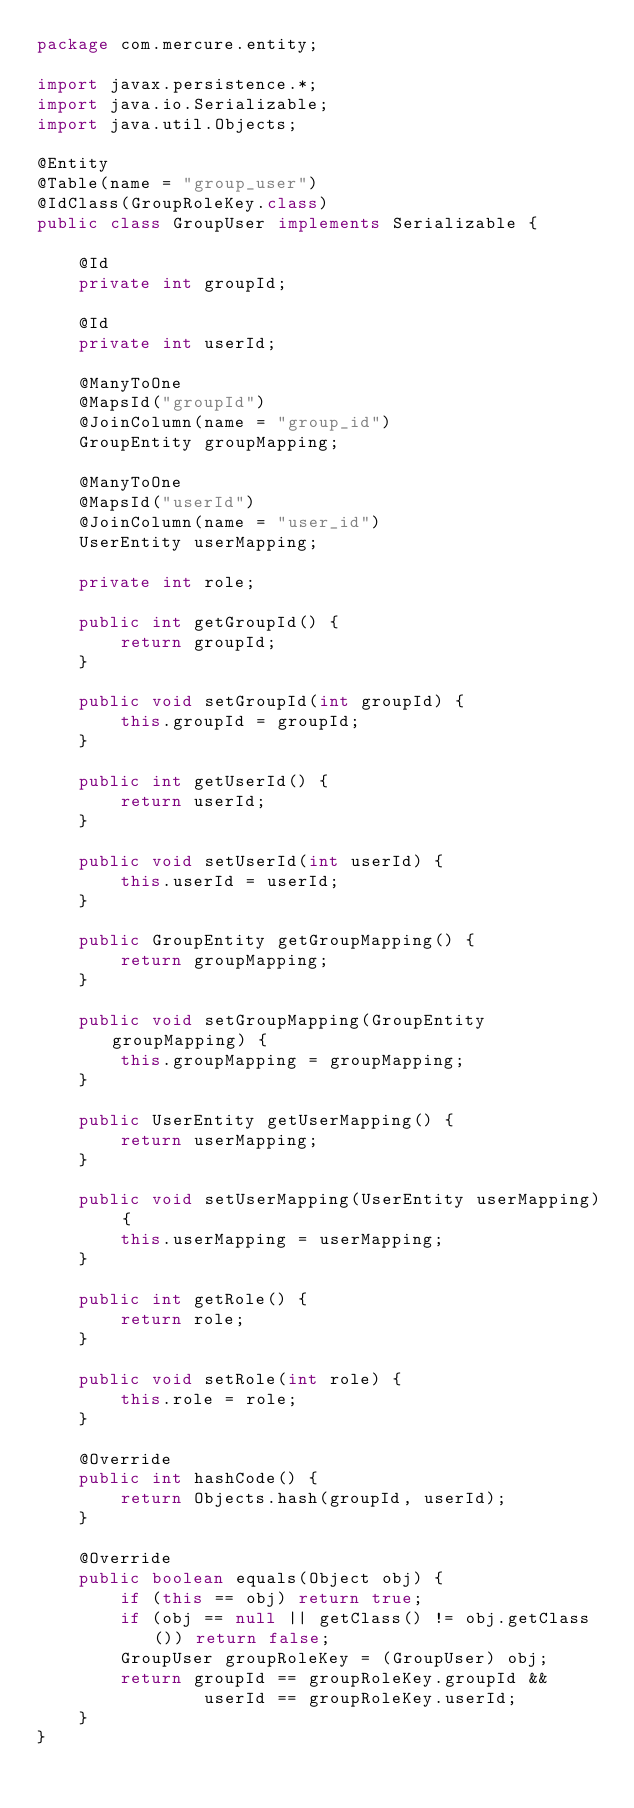Convert code to text. <code><loc_0><loc_0><loc_500><loc_500><_Java_>package com.mercure.entity;

import javax.persistence.*;
import java.io.Serializable;
import java.util.Objects;

@Entity
@Table(name = "group_user")
@IdClass(GroupRoleKey.class)
public class GroupUser implements Serializable {

    @Id
    private int groupId;

    @Id
    private int userId;

    @ManyToOne
    @MapsId("groupId")
    @JoinColumn(name = "group_id")
    GroupEntity groupMapping;

    @ManyToOne
    @MapsId("userId")
    @JoinColumn(name = "user_id")
    UserEntity userMapping;

    private int role;

    public int getGroupId() {
        return groupId;
    }

    public void setGroupId(int groupId) {
        this.groupId = groupId;
    }

    public int getUserId() {
        return userId;
    }

    public void setUserId(int userId) {
        this.userId = userId;
    }

    public GroupEntity getGroupMapping() {
        return groupMapping;
    }

    public void setGroupMapping(GroupEntity groupMapping) {
        this.groupMapping = groupMapping;
    }

    public UserEntity getUserMapping() {
        return userMapping;
    }

    public void setUserMapping(UserEntity userMapping) {
        this.userMapping = userMapping;
    }

    public int getRole() {
        return role;
    }

    public void setRole(int role) {
        this.role = role;
    }

    @Override
    public int hashCode() {
        return Objects.hash(groupId, userId);
    }

    @Override
    public boolean equals(Object obj) {
        if (this == obj) return true;
        if (obj == null || getClass() != obj.getClass()) return false;
        GroupUser groupRoleKey = (GroupUser) obj;
        return groupId == groupRoleKey.groupId &&
                userId == groupRoleKey.userId;
    }
}
</code> 